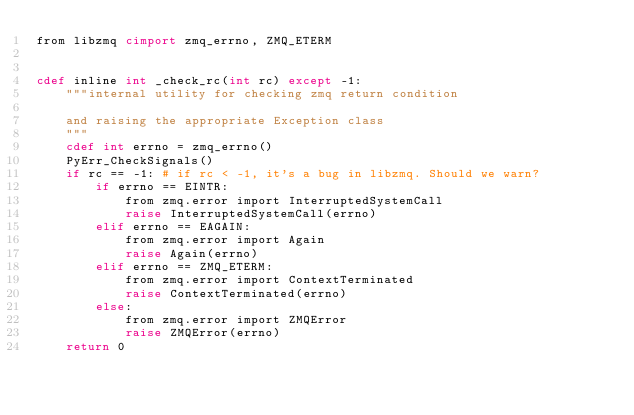Convert code to text. <code><loc_0><loc_0><loc_500><loc_500><_Cython_>from libzmq cimport zmq_errno, ZMQ_ETERM


cdef inline int _check_rc(int rc) except -1:
    """internal utility for checking zmq return condition
    
    and raising the appropriate Exception class
    """
    cdef int errno = zmq_errno()
    PyErr_CheckSignals()
    if rc == -1: # if rc < -1, it's a bug in libzmq. Should we warn?
        if errno == EINTR:
            from zmq.error import InterruptedSystemCall
            raise InterruptedSystemCall(errno)
        elif errno == EAGAIN:
            from zmq.error import Again
            raise Again(errno)
        elif errno == ZMQ_ETERM:
            from zmq.error import ContextTerminated
            raise ContextTerminated(errno)
        else:
            from zmq.error import ZMQError
            raise ZMQError(errno)
    return 0
</code> 